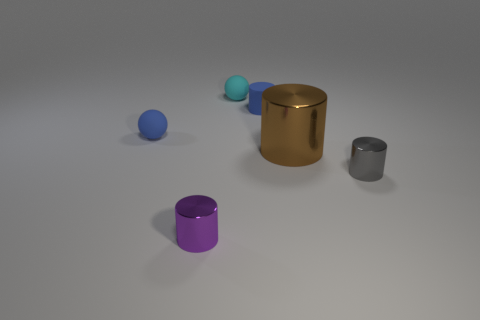What material is the other blue object that is the same shape as the big object?
Offer a terse response. Rubber. Are there any other things that have the same size as the cyan matte thing?
Your answer should be very brief. Yes. Is the number of tiny blue cylinders right of the big brown cylinder the same as the number of balls that are behind the tiny cyan matte sphere?
Ensure brevity in your answer.  Yes. Are there any objects made of the same material as the purple cylinder?
Make the answer very short. Yes. Do the small blue sphere and the cyan ball have the same material?
Your response must be concise. Yes. How many cyan objects are either rubber cubes or small matte balls?
Your answer should be very brief. 1. Is the number of gray metallic cylinders that are on the right side of the small gray object greater than the number of blue spheres?
Your answer should be compact. No. Are there any other tiny rubber cylinders that have the same color as the small matte cylinder?
Offer a very short reply. No. What size is the blue cylinder?
Provide a succinct answer. Small. Is the color of the big cylinder the same as the rubber cylinder?
Provide a short and direct response. No. 